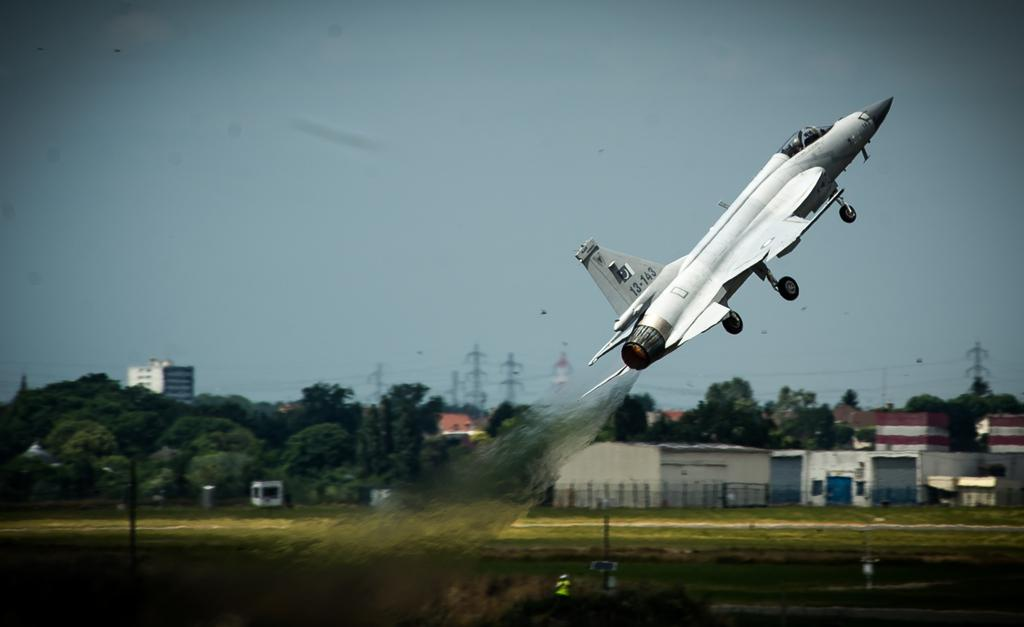Provide a one-sentence caption for the provided image. A military plane with call numbers 13-143 shoots up into the air. 